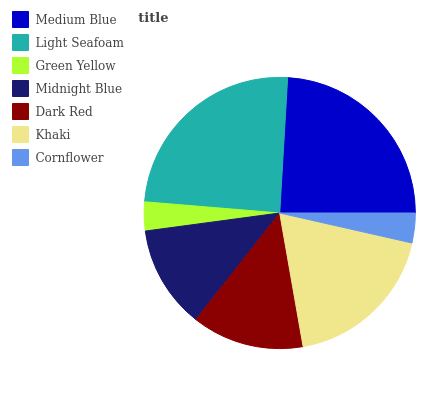Is Green Yellow the minimum?
Answer yes or no. Yes. Is Light Seafoam the maximum?
Answer yes or no. Yes. Is Light Seafoam the minimum?
Answer yes or no. No. Is Green Yellow the maximum?
Answer yes or no. No. Is Light Seafoam greater than Green Yellow?
Answer yes or no. Yes. Is Green Yellow less than Light Seafoam?
Answer yes or no. Yes. Is Green Yellow greater than Light Seafoam?
Answer yes or no. No. Is Light Seafoam less than Green Yellow?
Answer yes or no. No. Is Dark Red the high median?
Answer yes or no. Yes. Is Dark Red the low median?
Answer yes or no. Yes. Is Cornflower the high median?
Answer yes or no. No. Is Green Yellow the low median?
Answer yes or no. No. 